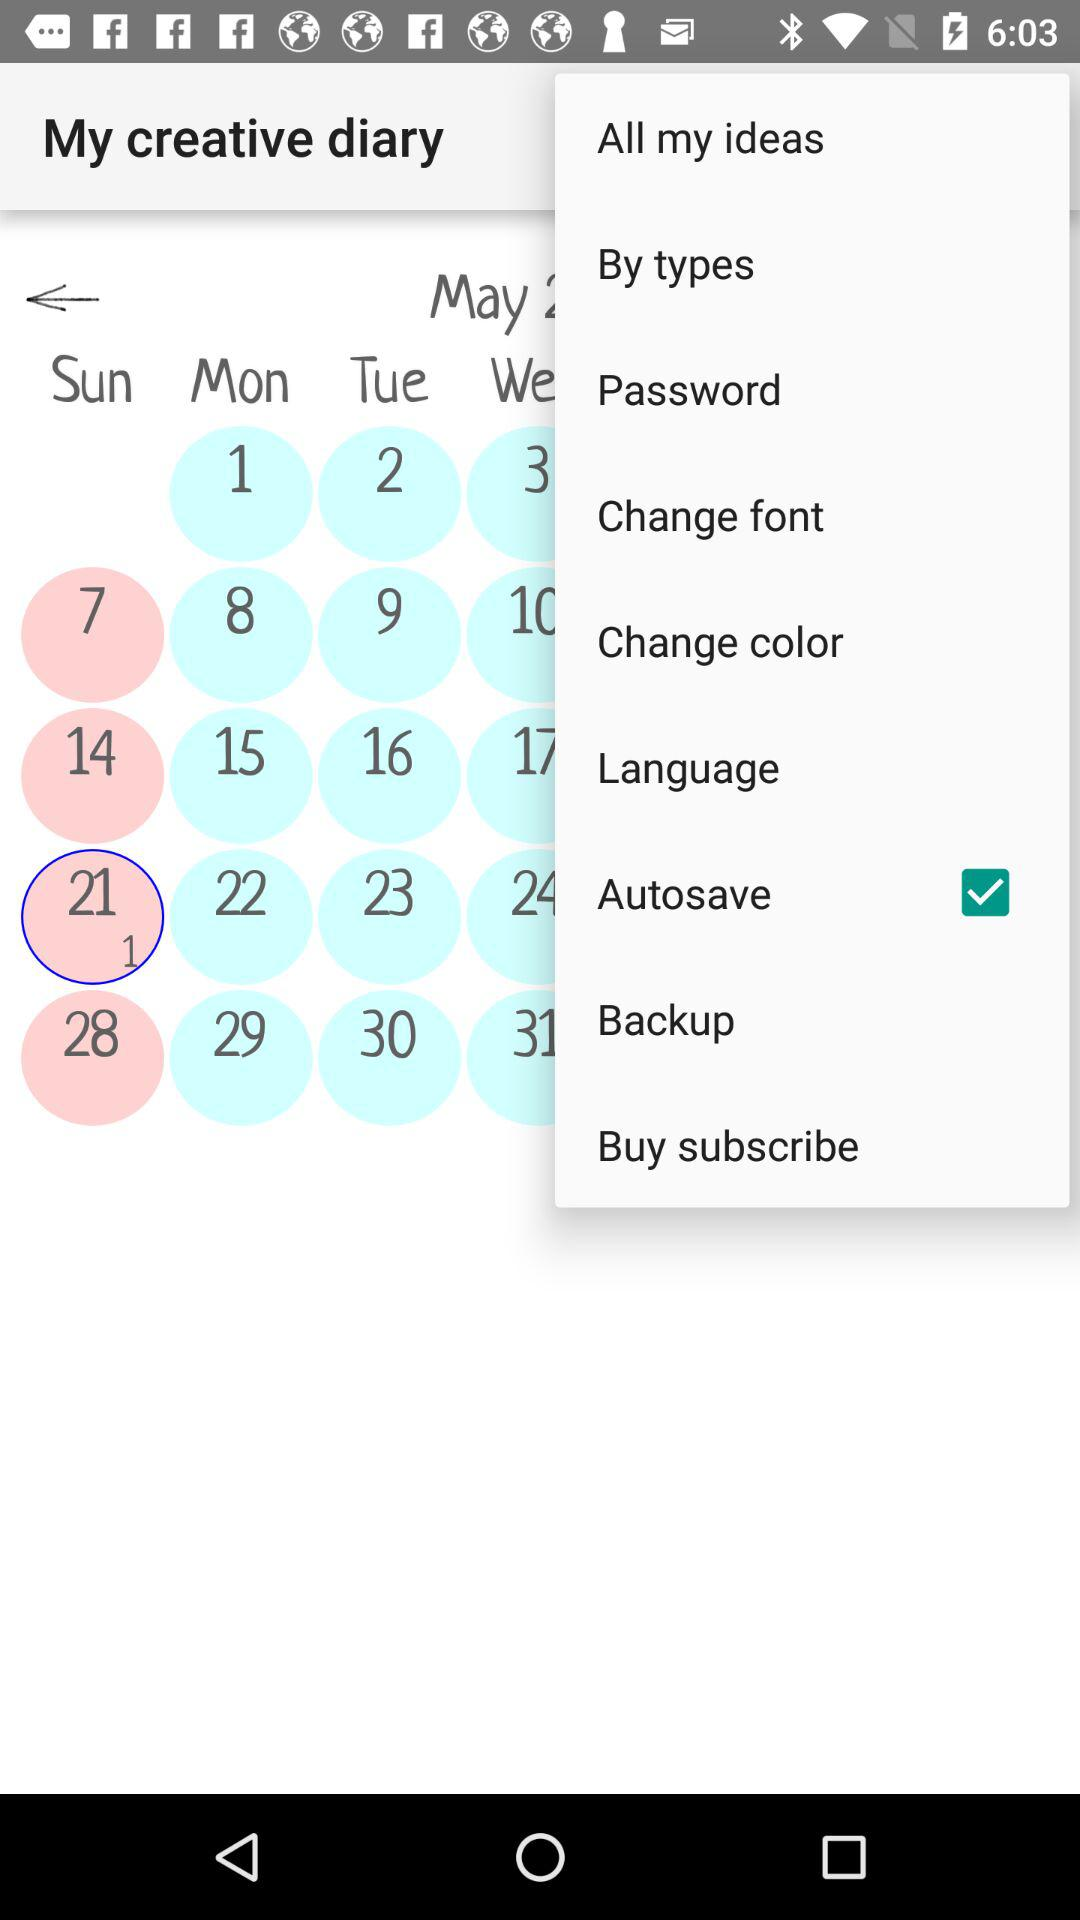What day is it on the selected date? The day is Sunday. 